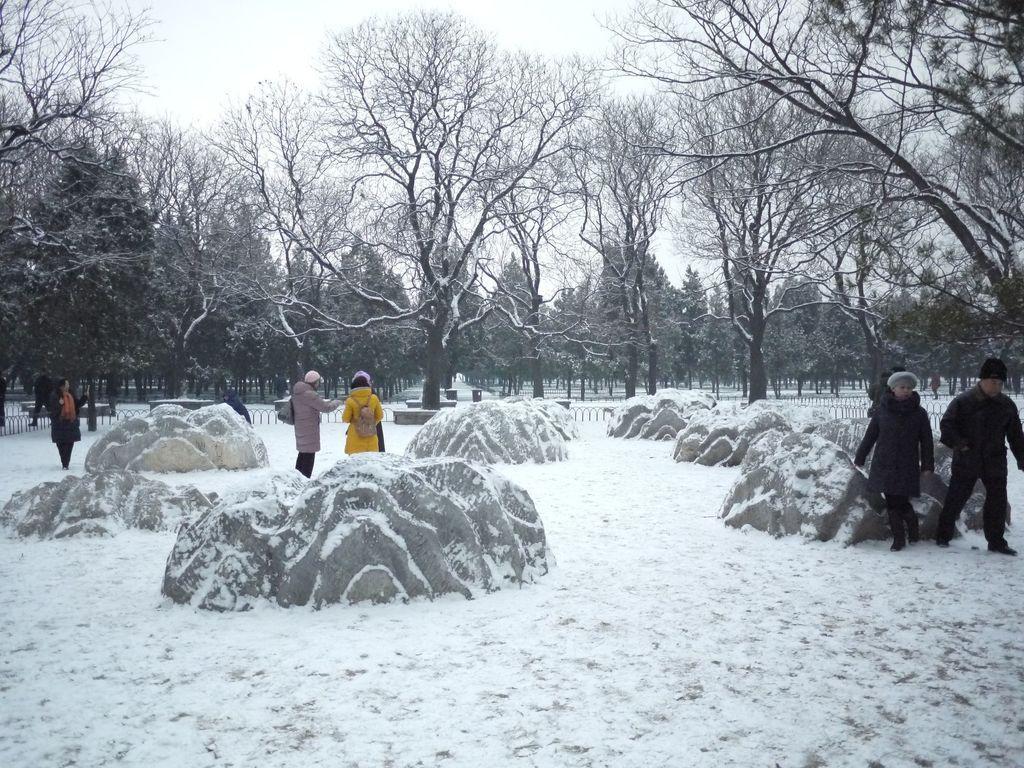How would you summarize this image in a sentence or two? In this image we can see persons standing on the ground, rocks, trees, sky and snow. 